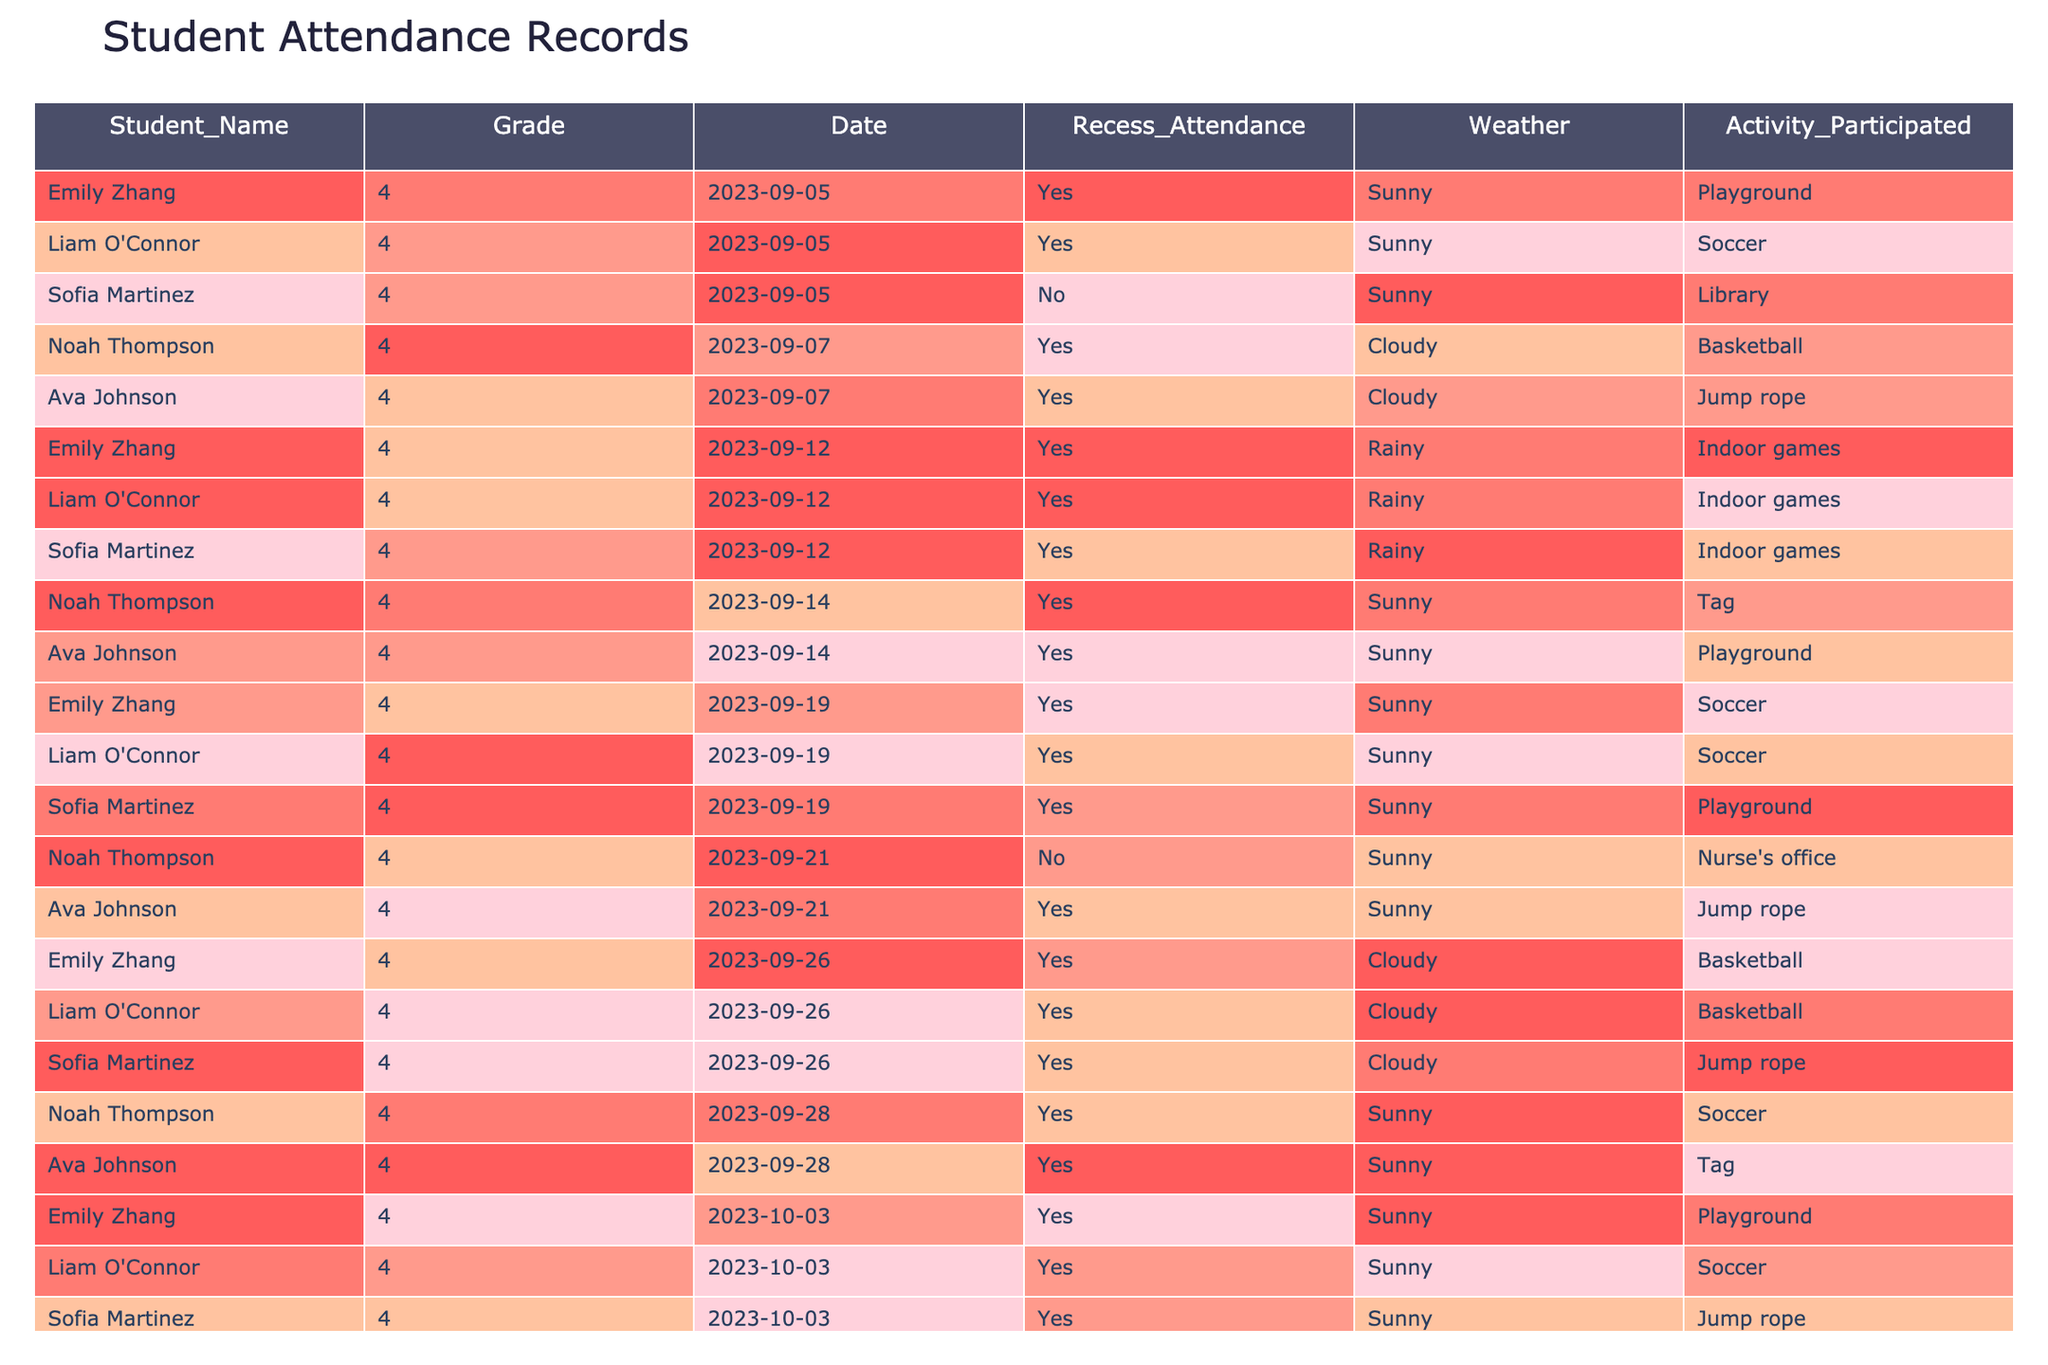What is the total number of days Emily Zhang attended recess? Emily attended recess on 7 occasions as seen in the table, specifically on the dates: September 5, September 7, September 12, September 14, September 19, September 26, and October 3.
Answer: 7 How many times did Sofia Martinez participate in outdoor recess activities? Sofia participated in outdoor recess activities on 5 occasions as reflected in the table and the activity column: September 5 (No, library), September 12, September 19 (Yes, Playground), September 26, and October 3. However, she did not attend on September 5. The total attendance is 4 based on the data.
Answer: 4 On which date did Noah Thompson not attend recess? Noah did not attend recess on September 21, as indicated by the "No" in the Recess Attendance column for that date. The entry also states he went to the nurse's office.
Answer: September 21 Was there any day when Ava Johnson did not participate in recess activities? Ava Johnson attended recess every day listed in the table; there are no entries indicating attendance as "No". Thus, she participated every time.
Answer: No What was the weather like on the day with the highest participation in recess? On September 19, with 5 students attending (Emily, Liam, Sofia, Noah, and Ava) and the weather being Sunny, it can be identified as the day with the highest participation.
Answer: Sunny How many different activities did students participate in on September 12? On September 12, students participated in just one activity, which was "Indoor games." As all students present took part in this same activity, the total is one distinct activity on that day.
Answer: 1 What percentage of days did Liam O'Connor attend recess during the recorded period? Liam attended recess on 6 out of 9 total days recorded. (6/9) x 100 gives approximately 66.67%.
Answer: 66.67% Which activity was the most participated in by students during recess, according to the data? The activity of "Soccer" showed up multiple times (September 5, September 19, October 3) indicating that it's among the higher participated activities, as opposed to "Indoor games," which appeared only once. Therefore, "Soccer" had the highest frequency of participation.
Answer: Soccer How many students attended recess on September 28? On September 28, both Noah and Ava attended recess, leading to a total of 2 students present.
Answer: 2 Did any students attend recess on a rainy day? Yes, the table shows that multiple students attended recess on the rainy days of September 12 and October 5, participating in "Indoor games." Therefore, attendance did occur on rainy days.
Answer: Yes 